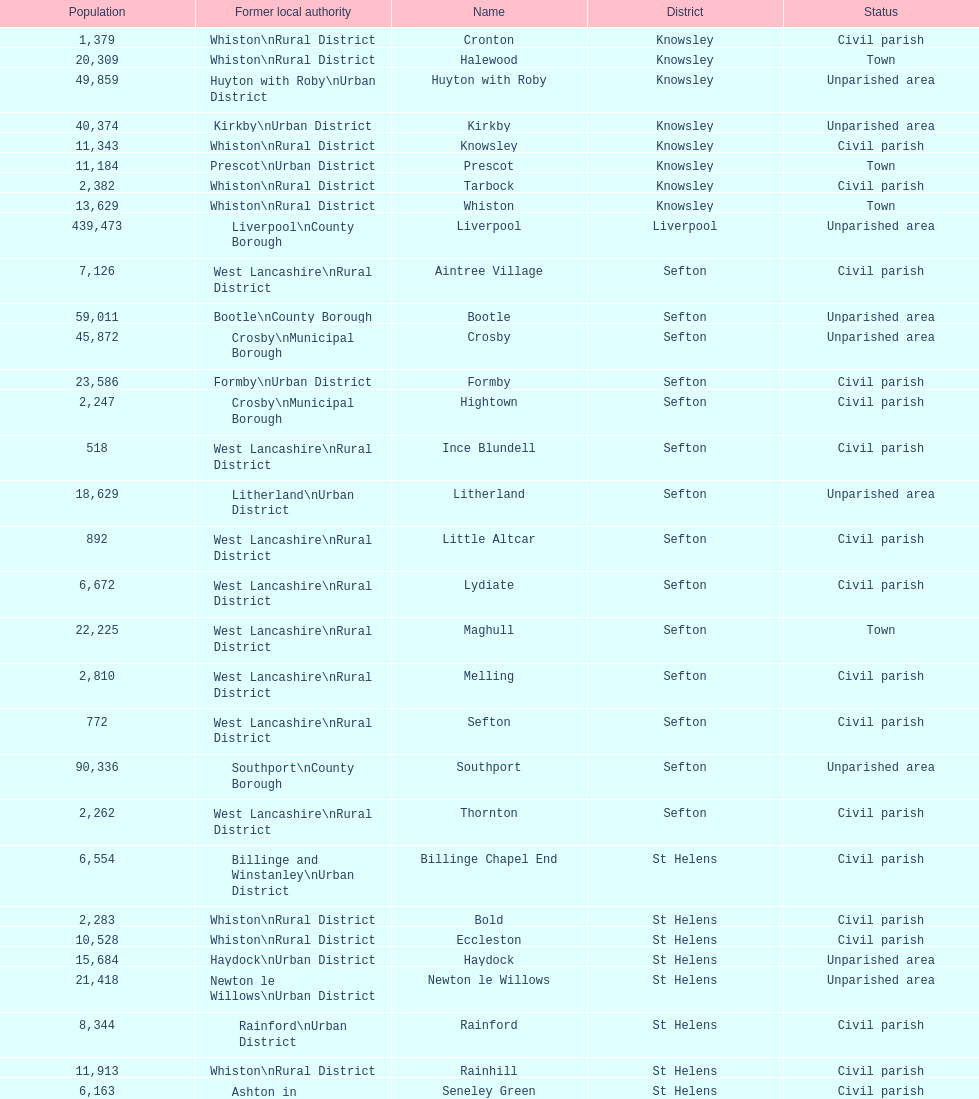How many areas are unparished areas? 15. 